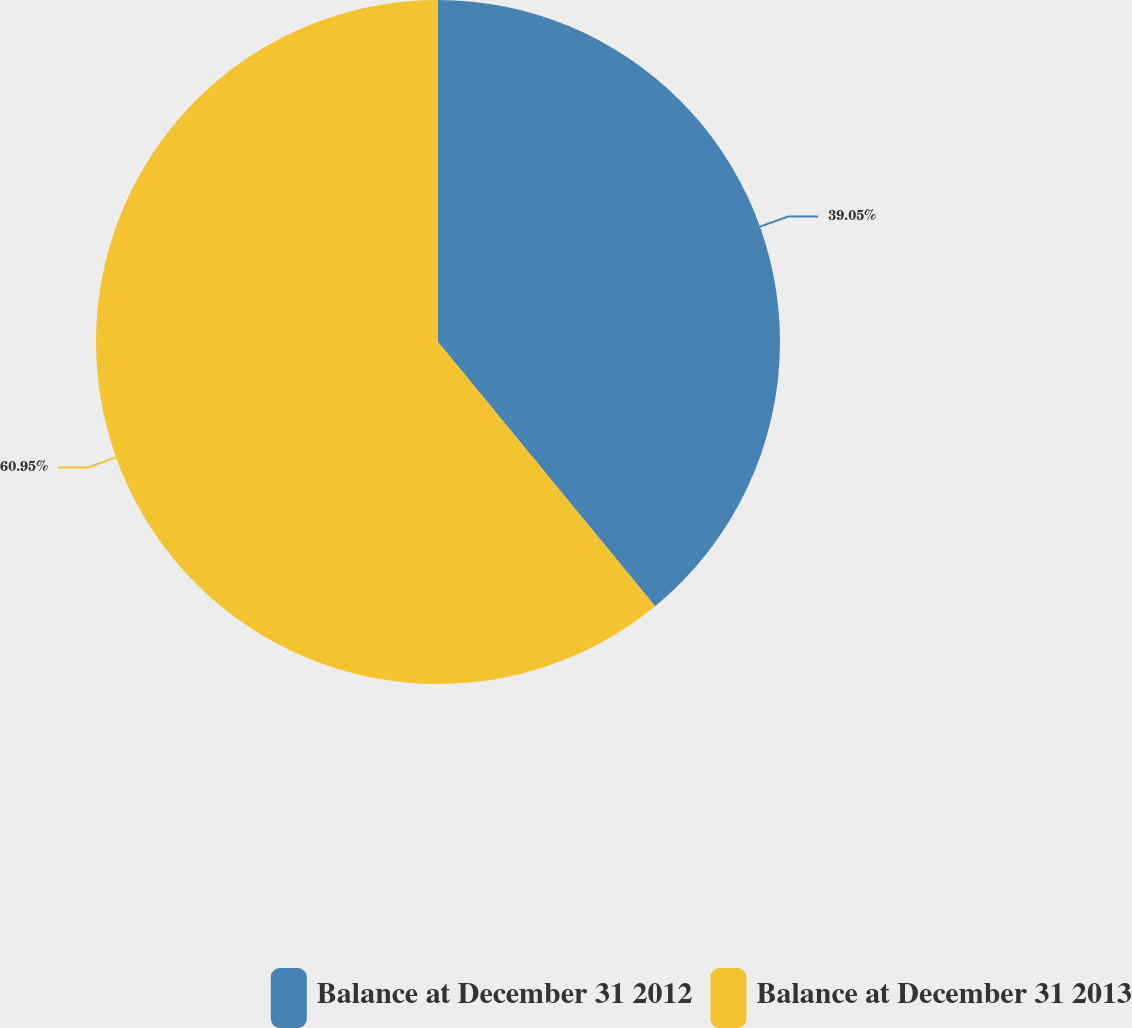Convert chart. <chart><loc_0><loc_0><loc_500><loc_500><pie_chart><fcel>Balance at December 31 2012<fcel>Balance at December 31 2013<nl><fcel>39.05%<fcel>60.95%<nl></chart> 